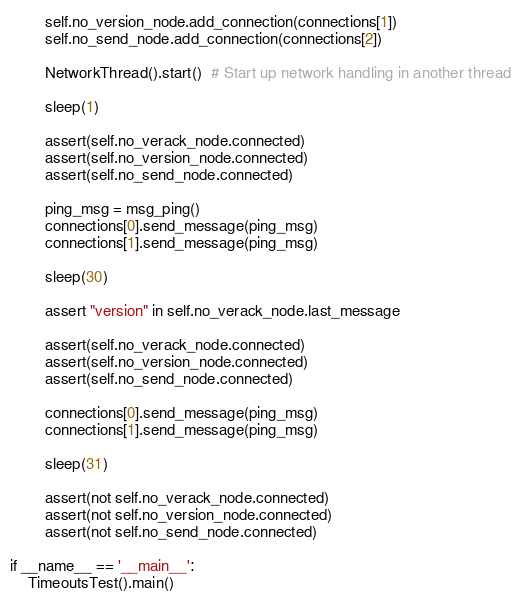<code> <loc_0><loc_0><loc_500><loc_500><_Python_>        self.no_version_node.add_connection(connections[1])
        self.no_send_node.add_connection(connections[2])

        NetworkThread().start()  # Start up network handling in another thread

        sleep(1)

        assert(self.no_verack_node.connected)
        assert(self.no_version_node.connected)
        assert(self.no_send_node.connected)

        ping_msg = msg_ping()
        connections[0].send_message(ping_msg)
        connections[1].send_message(ping_msg)

        sleep(30)

        assert "version" in self.no_verack_node.last_message

        assert(self.no_verack_node.connected)
        assert(self.no_version_node.connected)
        assert(self.no_send_node.connected)

        connections[0].send_message(ping_msg)
        connections[1].send_message(ping_msg)

        sleep(31)

        assert(not self.no_verack_node.connected)
        assert(not self.no_version_node.connected)
        assert(not self.no_send_node.connected)

if __name__ == '__main__':
    TimeoutsTest().main()
</code> 